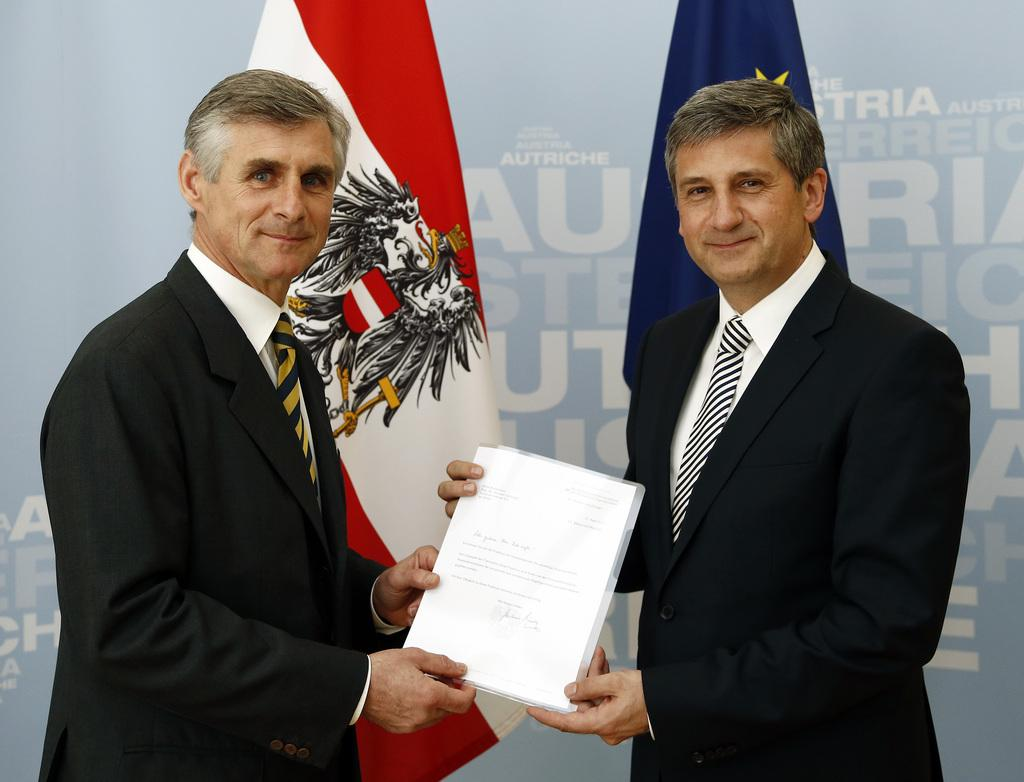How many people are present in the image? There are two persons in the image. What are the persons holding in their hands? The persons are holding papers. What can be seen in the background of the image? There are flags visible in the background, as well as a board with text. What type of potato is being grown on the hill in the image? There is no hill or potato present in the image. What is the size of the canvas on which the persons are working in the image? There is no canvas present in the image; the persons are holding papers. 